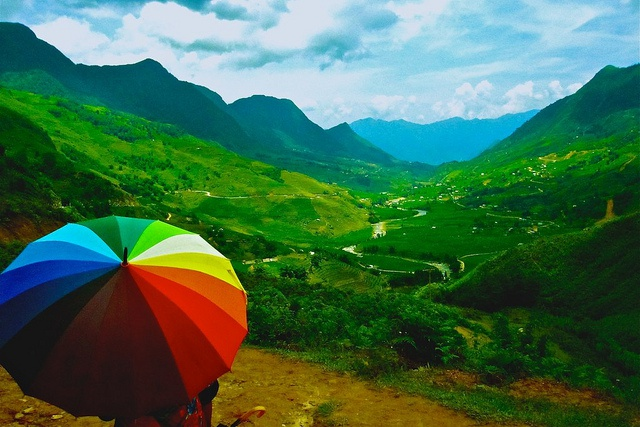Describe the objects in this image and their specific colors. I can see umbrella in lightblue, black, maroon, and red tones, people in lightblue, black, maroon, and olive tones, and umbrella in lightblue, maroon, black, brown, and olive tones in this image. 